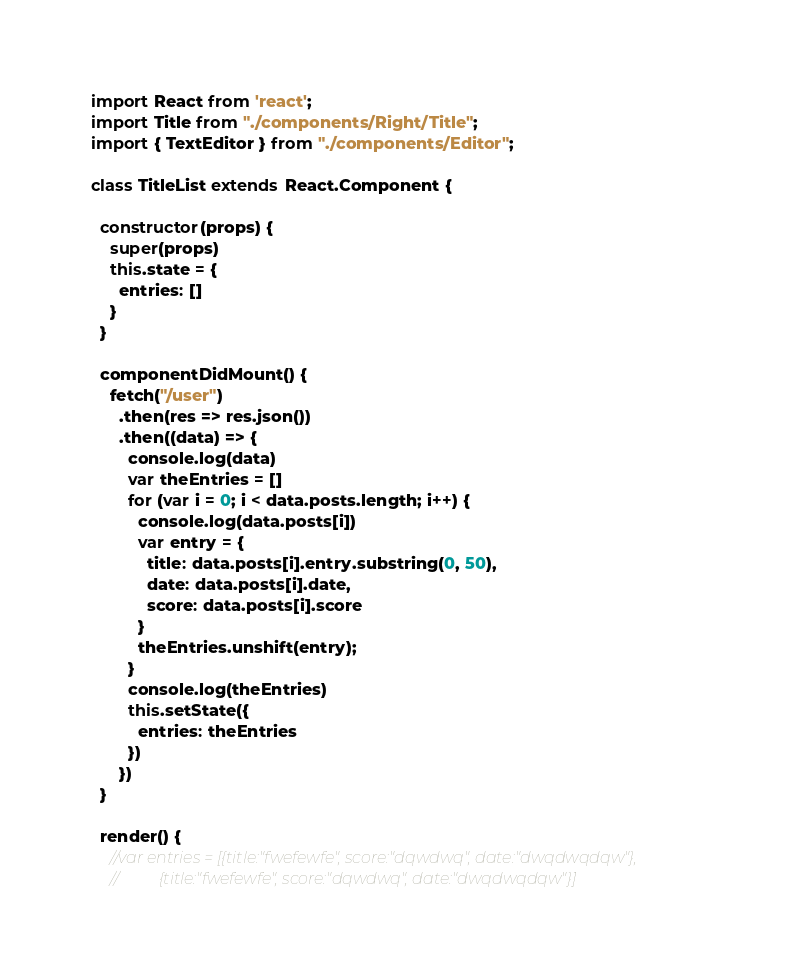Convert code to text. <code><loc_0><loc_0><loc_500><loc_500><_JavaScript_>import React from 'react';
import Title from "./components/Right/Title";
import { TextEditor } from "./components/Editor";

class TitleList extends React.Component {

  constructor(props) {
    super(props)
    this.state = {
      entries: []
    }
  }

  componentDidMount() {
    fetch("/user")
      .then(res => res.json())
      .then((data) => {
        console.log(data)
        var theEntries = []
        for (var i = 0; i < data.posts.length; i++) {
          console.log(data.posts[i])
          var entry = {
            title: data.posts[i].entry.substring(0, 50),
            date: data.posts[i].date,
            score: data.posts[i].score
          }
          theEntries.unshift(entry);
        }
        console.log(theEntries)
        this.setState({
          entries: theEntries
        })
      })
  }

  render() {
    //var entries = [{title:"fwefewfe", score:"dqwdwq", date:"dwqdwqdqw"},
    //          {title:"fwefewfe", score:"dqwdwq", date:"dwqdwqdqw"}]
</code> 